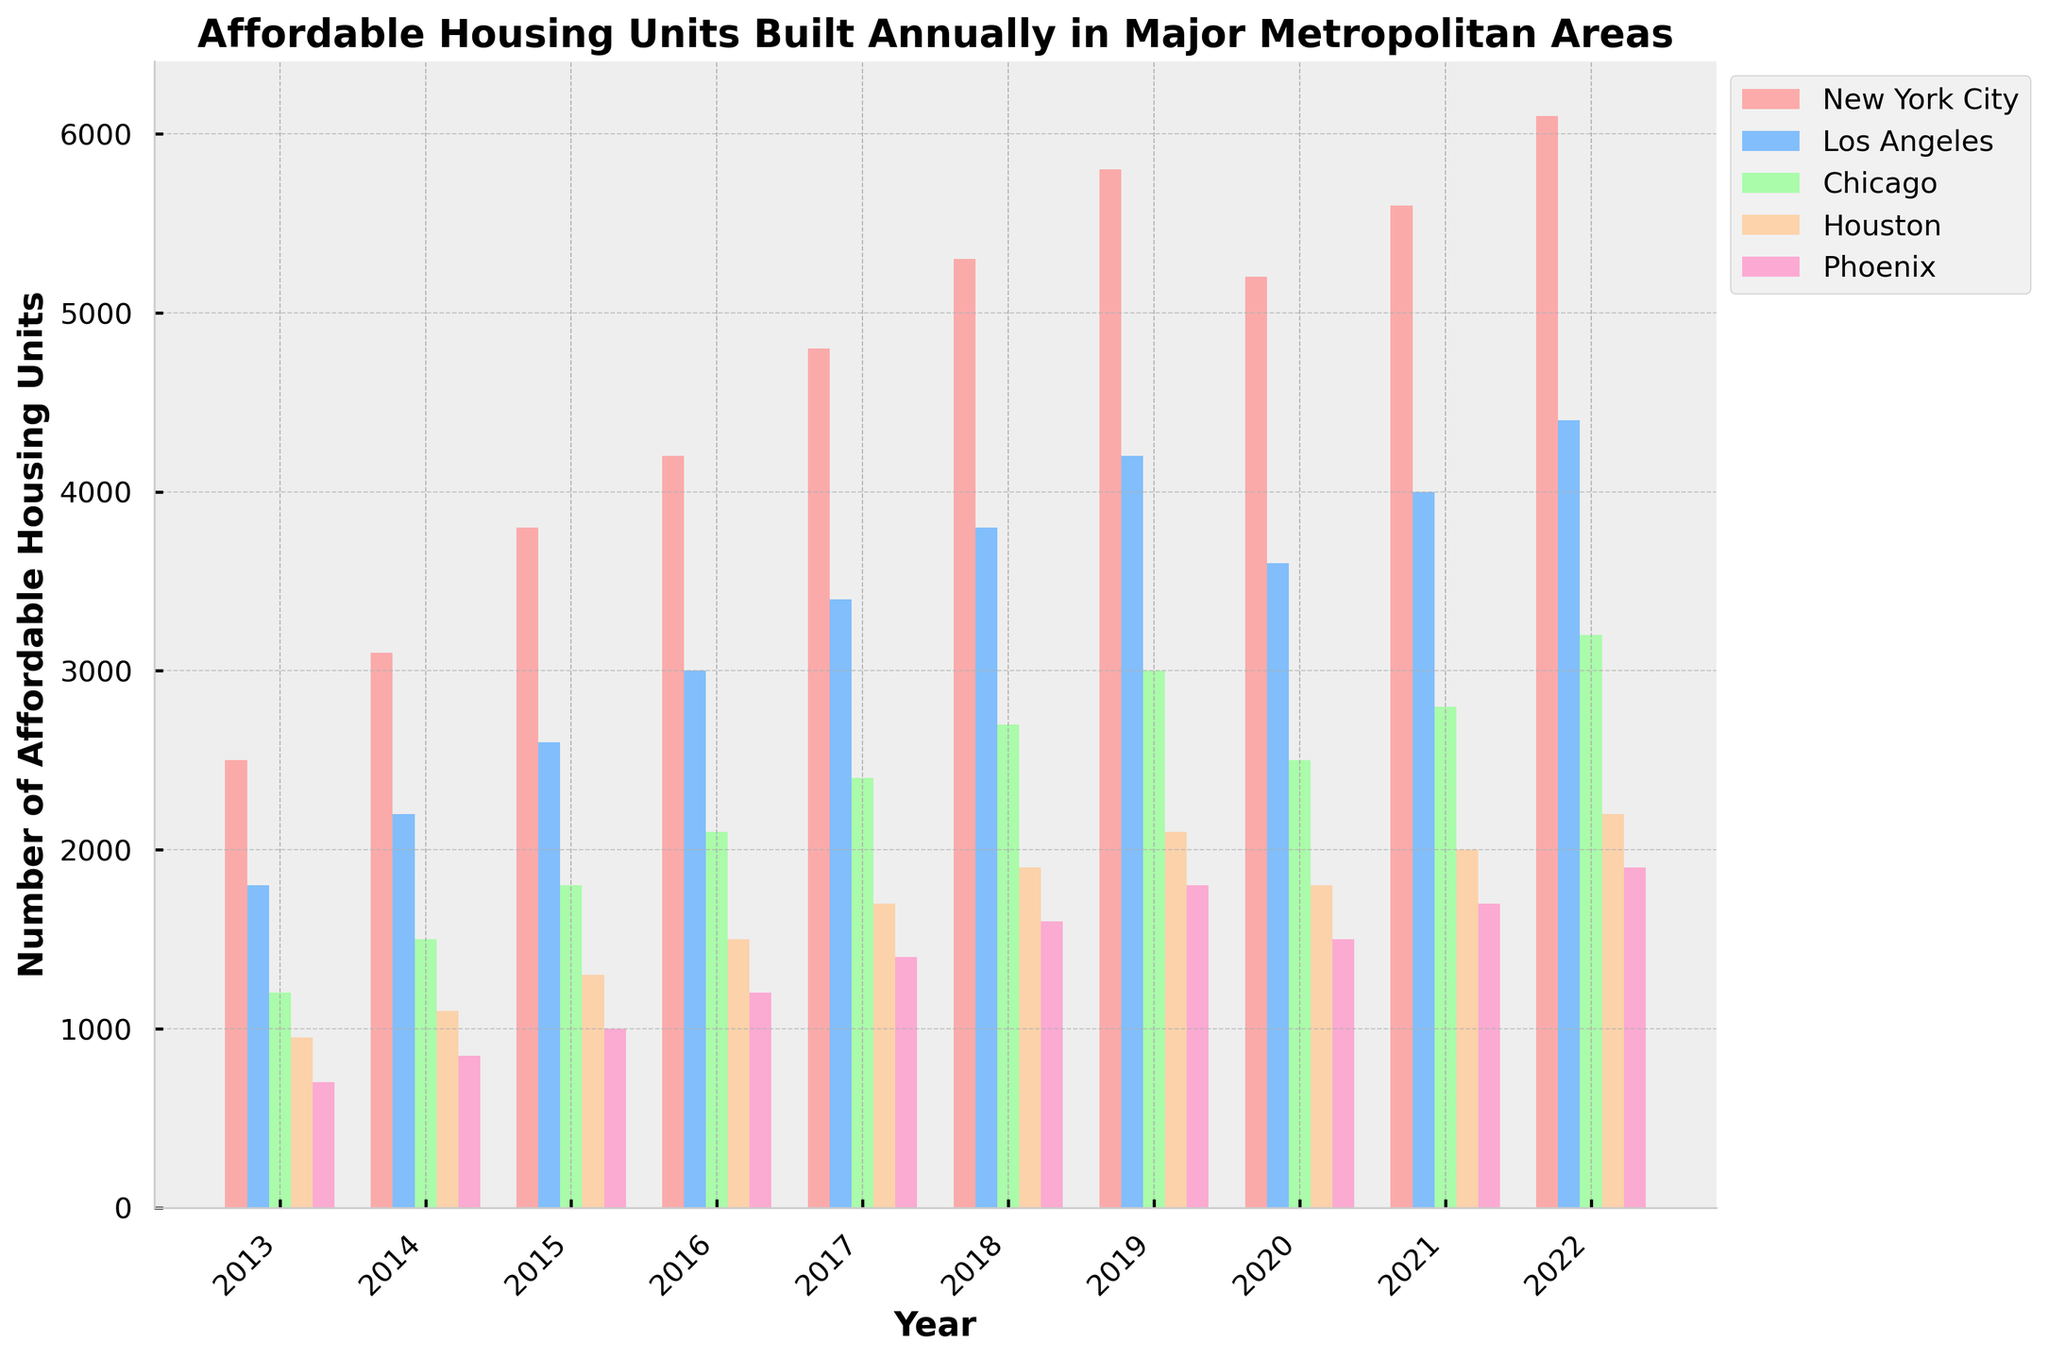What year did New York City build the most affordable housing units? The bar for New York City in 2022 is the tallest, indicating the highest number of units built that year.
Answer: 2022 In which year did Phoenix see the greatest increase in affordable housing units compared to the previous year? The difference between the heights of Phoenix's bars from one year to the next is greatest between 2018 (1600 units) and 2017 (1400 units), an increase of 200 units.
Answer: 2018 Which city built more affordable housing units in 2020, Los Angeles or Chicago? Comparing the heights of the bars in 2020, Los Angeles' bar (3600 units) is taller than Chicago's bar (2500 units).
Answer: Los Angeles What's the difference in the number of affordable housing units built between the city with the highest and the city with the lowest units in 2022? In 2022, New York City built 6100 units and Phoenix built 1900 units. The difference is 6100 - 1900 = 4200 units.
Answer: 4200 How many total affordable housing units were built in Houston over the entire decade? Sum the number of units built in Houston each year: 950 + 1100 + 1300 + 1500 + 1700 + 1900 + 2100 + 1800 + 2000 + 2200 = 16550.
Answer: 16,550 What is the average number of affordable housing units built annually in Los Angeles from 2013 to 2017? Sum the units for 2013-2017 and divide by 5 years: (1800 + 2200 + 2600 + 3000 + 3400) / 5 = 13000 / 5 = 2600.
Answer: 2600 Which city had the least variation in the number of affordable housing units built over the decade? Phoenix's bar heights are closer together compared to other cities, indicating less variation.
Answer: Phoenix In which year did all cities combined build the highest number of affordable housing units? Summing the heights of all bars for each year and comparing, 2022 has the highest total: 6100 + 4400 + 3200 + 2200 + 1900 = 17800 units.
Answer: 2022 Did New York City build more or fewer affordable housing units in 2020 compared to 2019? Comparing the heights of the bars, New York City built 5800 units in 2019 and 5200 units in 2020, indicating fewer units were built in 2020.
Answer: Fewer 